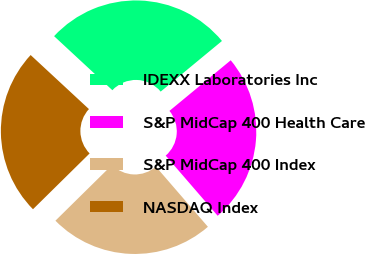Convert chart to OTSL. <chart><loc_0><loc_0><loc_500><loc_500><pie_chart><fcel>IDEXX Laboratories Inc<fcel>S&P MidCap 400 Health Care<fcel>S&P MidCap 400 Index<fcel>NASDAQ Index<nl><fcel>27.11%<fcel>24.64%<fcel>23.96%<fcel>24.28%<nl></chart> 